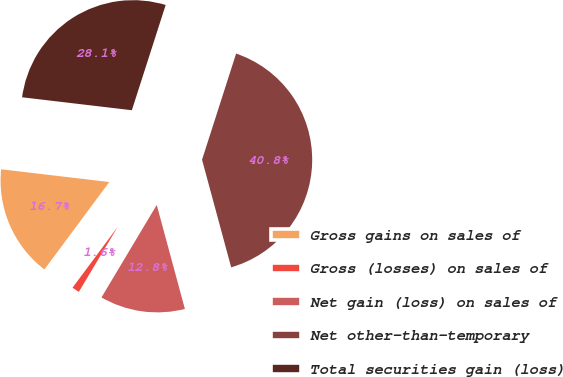<chart> <loc_0><loc_0><loc_500><loc_500><pie_chart><fcel>Gross gains on sales of<fcel>Gross (losses) on sales of<fcel>Net gain (loss) on sales of<fcel>Net other-than-temporary<fcel>Total securities gain (loss)<nl><fcel>16.71%<fcel>1.59%<fcel>12.78%<fcel>40.85%<fcel>28.08%<nl></chart> 